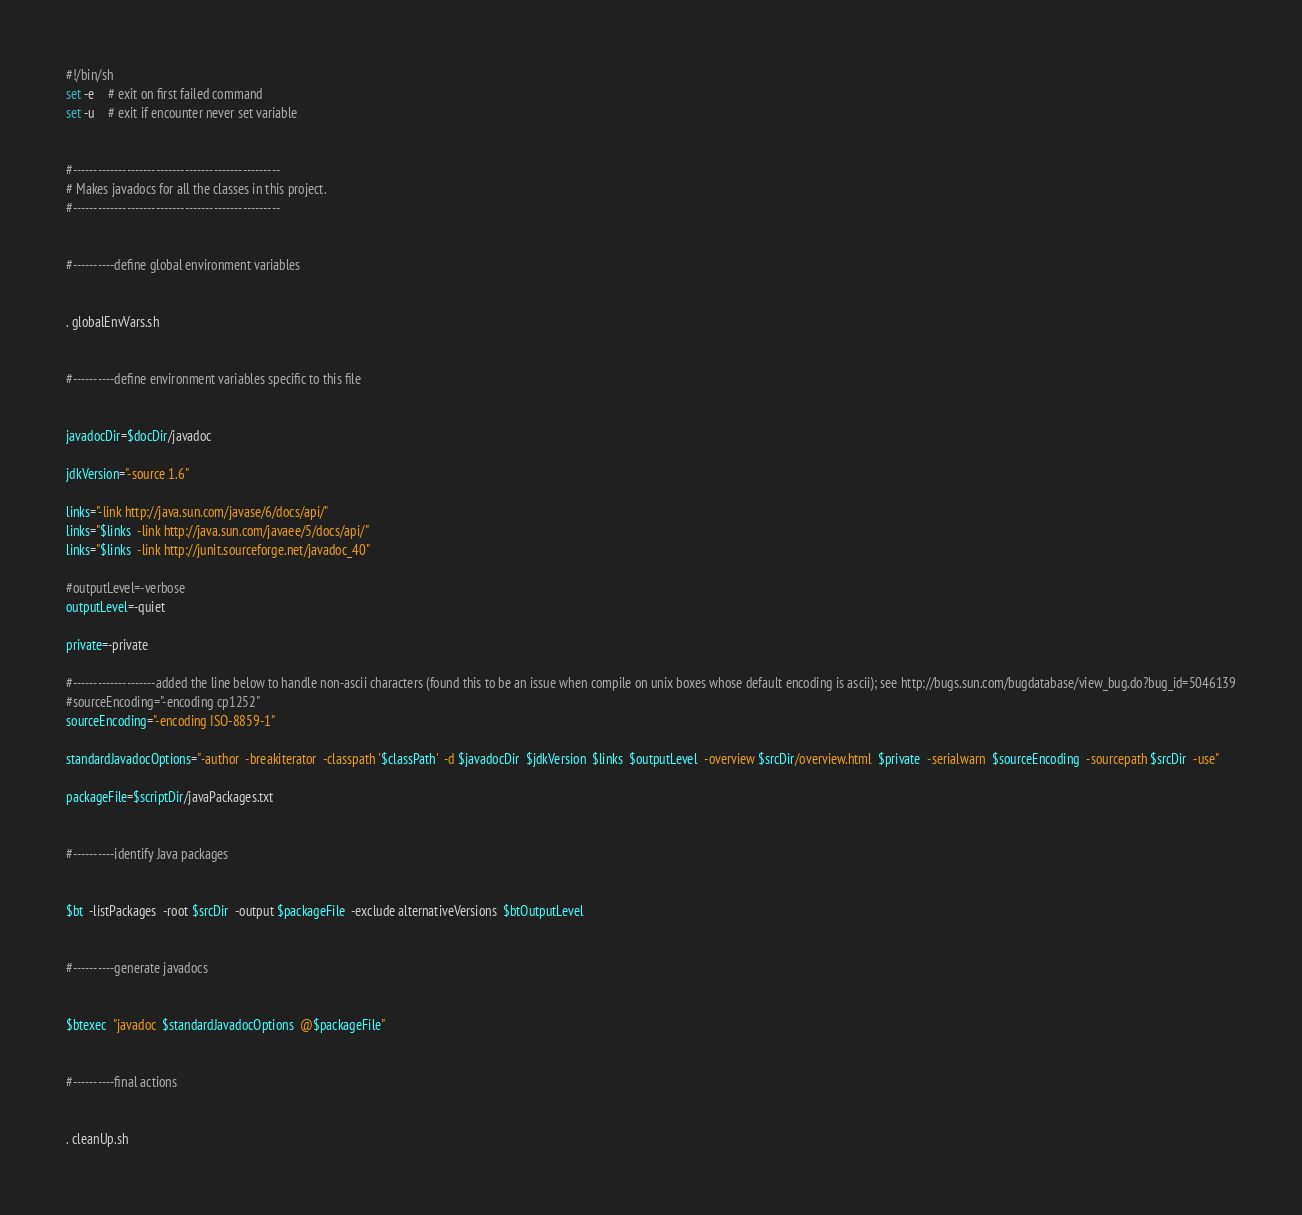<code> <loc_0><loc_0><loc_500><loc_500><_Bash_>#!/bin/sh
set -e	# exit on first failed command
set -u	# exit if encounter never set variable


#--------------------------------------------------
# Makes javadocs for all the classes in this project.
#--------------------------------------------------


#----------define global environment variables


. globalEnvVars.sh


#----------define environment variables specific to this file


javadocDir=$docDir/javadoc

jdkVersion="-source 1.6"

links="-link http://java.sun.com/javase/6/docs/api/"
links="$links  -link http://java.sun.com/javaee/5/docs/api/"
links="$links  -link http://junit.sourceforge.net/javadoc_40"

#outputLevel=-verbose
outputLevel=-quiet

private=-private

#--------------------added the line below to handle non-ascii characters (found this to be an issue when compile on unix boxes whose default encoding is ascii); see http://bugs.sun.com/bugdatabase/view_bug.do?bug_id=5046139
#sourceEncoding="-encoding cp1252"
sourceEncoding="-encoding ISO-8859-1"

standardJavadocOptions="-author  -breakiterator  -classpath '$classPath'  -d $javadocDir  $jdkVersion  $links  $outputLevel  -overview $srcDir/overview.html  $private  -serialwarn  $sourceEncoding  -sourcepath $srcDir  -use"

packageFile=$scriptDir/javaPackages.txt


#----------identify Java packages


$bt  -listPackages  -root $srcDir  -output $packageFile  -exclude alternativeVersions  $btOutputLevel


#----------generate javadocs


$btexec  "javadoc  $standardJavadocOptions  @$packageFile"


#----------final actions


. cleanUp.sh
</code> 